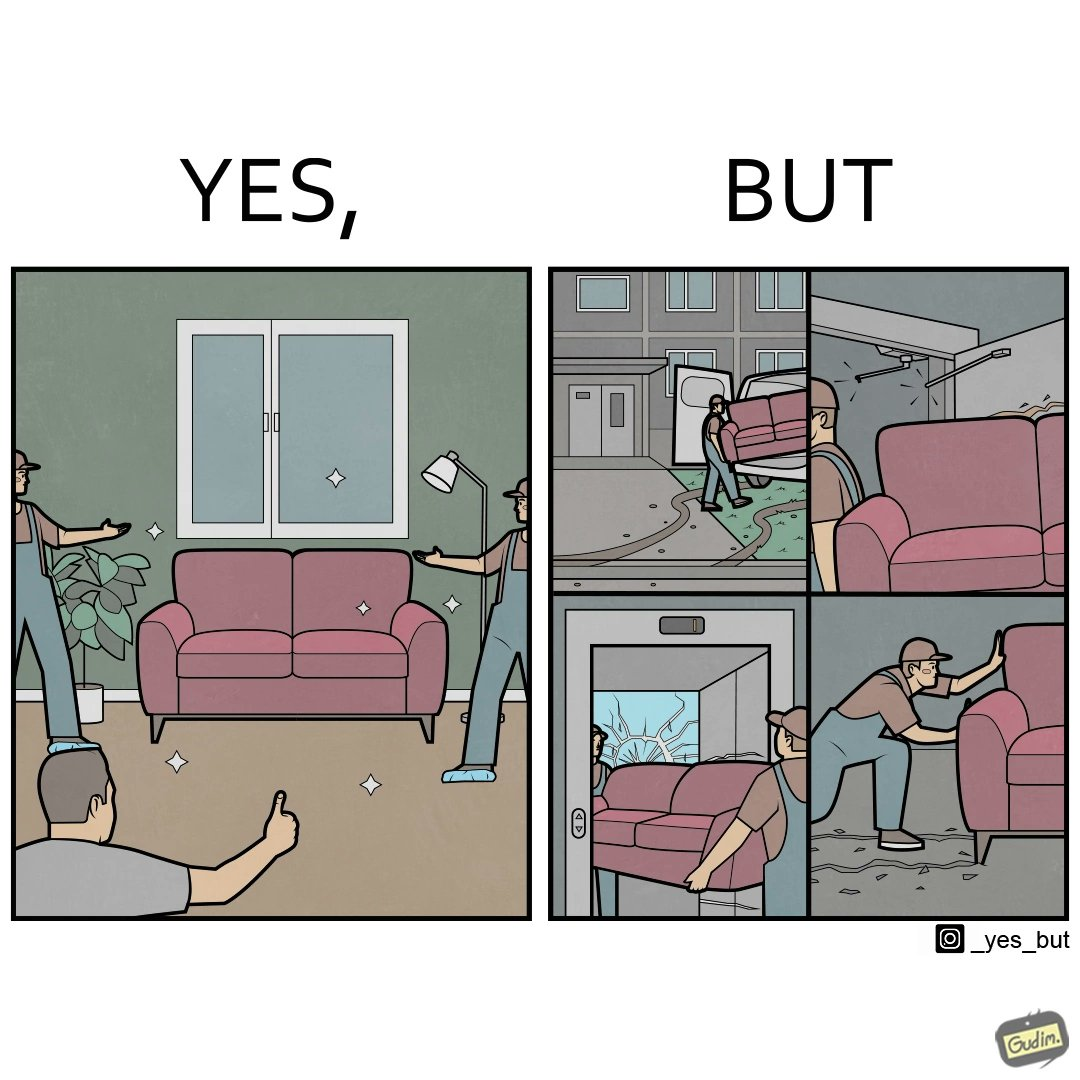Is this a satirical image? Yes, this image is satirical. 